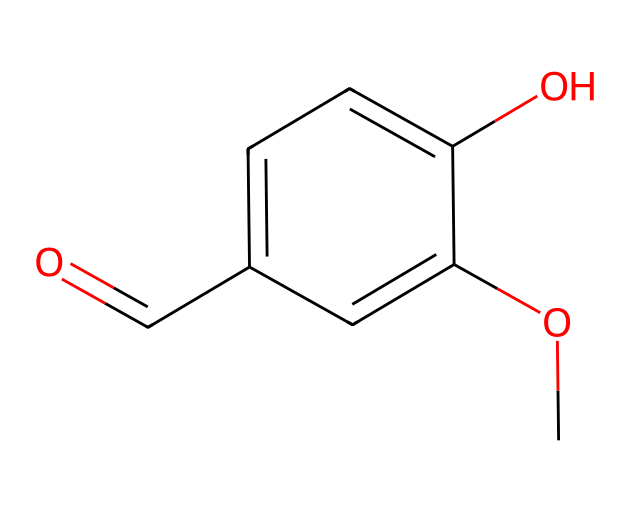What is the name of this chemical? The SMILES representation indicates that this compound is called vanillin, which is commonly known as a key component in vanilla fragrance.
Answer: vanillin How many hydrogen atoms are in the structure? The structure can be analyzed to count the hydrogen atoms: two on the methoxy group, one on the hydroxyl group, and five attached to the carbon chain, totaling eight.
Answer: 8 What type of functional groups are present in this compound? In the SMILES representation, there are a methoxy (-OCH3) and a hydroxyl (-OH) functional group along with an aldehyde (-CHO). These groups define its reactivity and fragrance properties.
Answer: methoxy, hydroxyl, aldehyde What is the total number of carbon atoms in the structure? Counting through the SMILES, we find six carbon atoms in the aromatic ring, one in the methoxy group (CH3), and one in the aldehyde group (C=O), resulting in a total of eight carbon atoms.
Answer: 8 Which part of the chemical contributes to its sweet flavor? The carbonyl group in the aldehyde function contributes to the sweet flavor profile, along with the aromatic structure that enhances its pleasant smell.
Answer: carbonyl group Does this compound exhibit acidity? Yes, the presence of the hydroxyl group allows for acidity as it can donate a hydrogen ion (proton) in aqueous solutions, making it a weak acid.
Answer: yes 